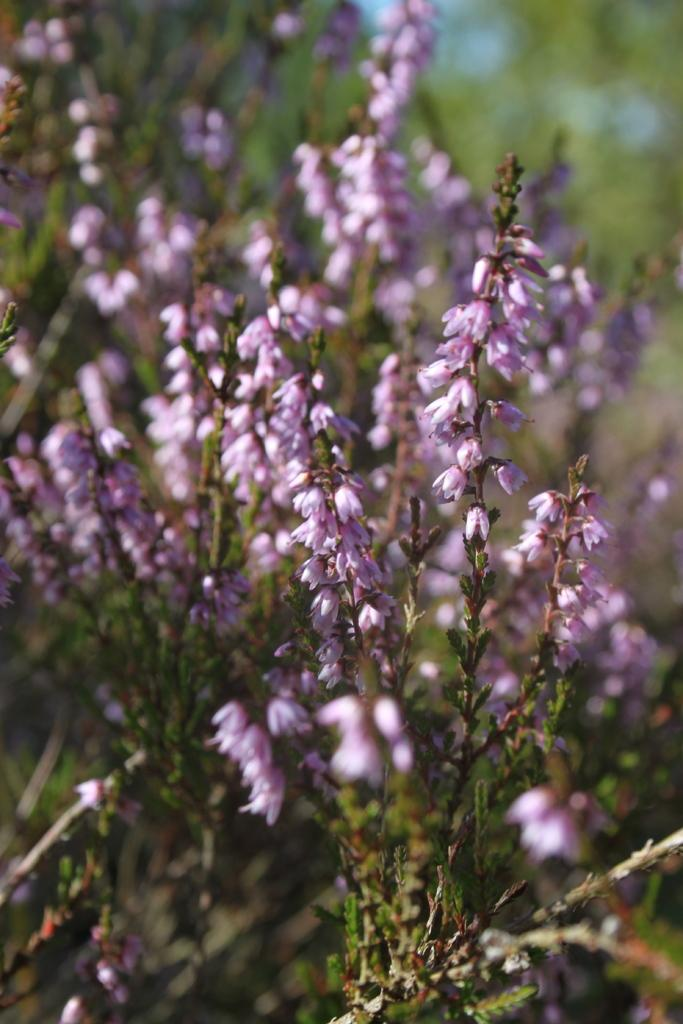What can be seen on the plants in the image? There are flowers on the plants in the image. What type of expansion is occurring with the flowers in the image? There is no indication of any expansion occurring with the flowers in the image. Can you see a robin perched on any of the plants in the image? There is no robin present in the image. 